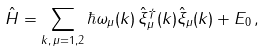<formula> <loc_0><loc_0><loc_500><loc_500>\hat { H } = \sum _ { k , \, \mu = 1 , 2 } \hbar { \omega } _ { \mu } ( k ) \, \hat { \xi } ^ { \dag } _ { \mu } ( k ) \hat { \xi } _ { \mu } ( k ) + E _ { 0 } \, ,</formula> 